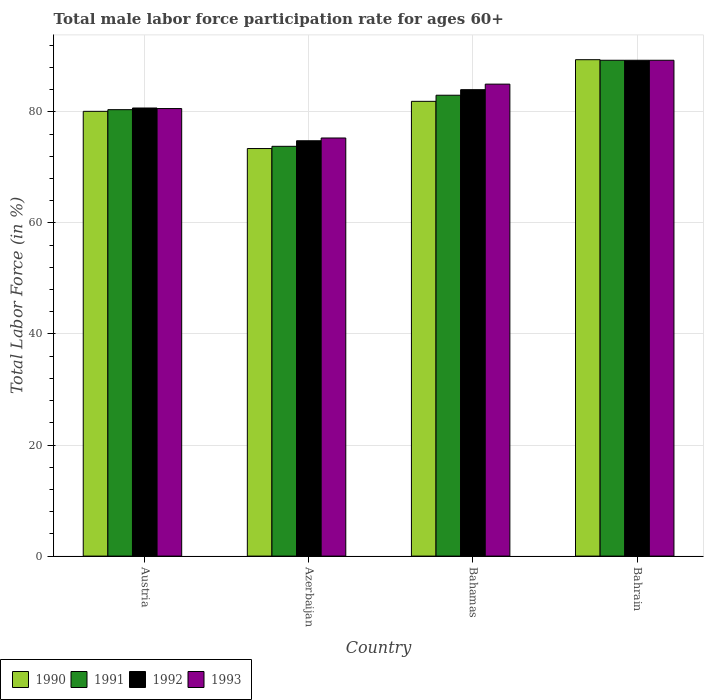What is the label of the 3rd group of bars from the left?
Your response must be concise. Bahamas. What is the male labor force participation rate in 1990 in Austria?
Your response must be concise. 80.1. Across all countries, what is the maximum male labor force participation rate in 1992?
Your response must be concise. 89.3. Across all countries, what is the minimum male labor force participation rate in 1990?
Offer a very short reply. 73.4. In which country was the male labor force participation rate in 1993 maximum?
Provide a short and direct response. Bahrain. In which country was the male labor force participation rate in 1992 minimum?
Make the answer very short. Azerbaijan. What is the total male labor force participation rate in 1990 in the graph?
Your response must be concise. 324.8. What is the difference between the male labor force participation rate in 1991 in Bahamas and that in Bahrain?
Make the answer very short. -6.3. What is the difference between the male labor force participation rate in 1992 in Bahamas and the male labor force participation rate in 1990 in Bahrain?
Make the answer very short. -5.4. What is the average male labor force participation rate in 1990 per country?
Make the answer very short. 81.2. What is the difference between the male labor force participation rate of/in 1992 and male labor force participation rate of/in 1993 in Austria?
Offer a very short reply. 0.1. In how many countries, is the male labor force participation rate in 1993 greater than 56 %?
Offer a terse response. 4. What is the ratio of the male labor force participation rate in 1990 in Bahamas to that in Bahrain?
Offer a terse response. 0.92. Is the male labor force participation rate in 1992 in Austria less than that in Bahamas?
Provide a short and direct response. Yes. Is the difference between the male labor force participation rate in 1992 in Bahamas and Bahrain greater than the difference between the male labor force participation rate in 1993 in Bahamas and Bahrain?
Make the answer very short. No. What is the difference between the highest and the second highest male labor force participation rate in 1990?
Offer a terse response. -7.5. What is the difference between the highest and the lowest male labor force participation rate in 1990?
Ensure brevity in your answer.  16. What does the 1st bar from the right in Austria represents?
Your answer should be very brief. 1993. Are all the bars in the graph horizontal?
Offer a very short reply. No. How many countries are there in the graph?
Offer a very short reply. 4. Are the values on the major ticks of Y-axis written in scientific E-notation?
Keep it short and to the point. No. Does the graph contain any zero values?
Provide a succinct answer. No. Does the graph contain grids?
Your answer should be very brief. Yes. Where does the legend appear in the graph?
Your response must be concise. Bottom left. How many legend labels are there?
Your response must be concise. 4. What is the title of the graph?
Ensure brevity in your answer.  Total male labor force participation rate for ages 60+. Does "1970" appear as one of the legend labels in the graph?
Keep it short and to the point. No. What is the label or title of the Y-axis?
Your answer should be very brief. Total Labor Force (in %). What is the Total Labor Force (in %) in 1990 in Austria?
Provide a succinct answer. 80.1. What is the Total Labor Force (in %) of 1991 in Austria?
Provide a short and direct response. 80.4. What is the Total Labor Force (in %) in 1992 in Austria?
Make the answer very short. 80.7. What is the Total Labor Force (in %) in 1993 in Austria?
Make the answer very short. 80.6. What is the Total Labor Force (in %) in 1990 in Azerbaijan?
Provide a short and direct response. 73.4. What is the Total Labor Force (in %) of 1991 in Azerbaijan?
Give a very brief answer. 73.8. What is the Total Labor Force (in %) of 1992 in Azerbaijan?
Keep it short and to the point. 74.8. What is the Total Labor Force (in %) in 1993 in Azerbaijan?
Provide a succinct answer. 75.3. What is the Total Labor Force (in %) of 1990 in Bahamas?
Make the answer very short. 81.9. What is the Total Labor Force (in %) of 1993 in Bahamas?
Your response must be concise. 85. What is the Total Labor Force (in %) of 1990 in Bahrain?
Offer a terse response. 89.4. What is the Total Labor Force (in %) in 1991 in Bahrain?
Provide a succinct answer. 89.3. What is the Total Labor Force (in %) of 1992 in Bahrain?
Give a very brief answer. 89.3. What is the Total Labor Force (in %) in 1993 in Bahrain?
Ensure brevity in your answer.  89.3. Across all countries, what is the maximum Total Labor Force (in %) in 1990?
Provide a succinct answer. 89.4. Across all countries, what is the maximum Total Labor Force (in %) in 1991?
Your answer should be compact. 89.3. Across all countries, what is the maximum Total Labor Force (in %) in 1992?
Your answer should be compact. 89.3. Across all countries, what is the maximum Total Labor Force (in %) in 1993?
Provide a short and direct response. 89.3. Across all countries, what is the minimum Total Labor Force (in %) in 1990?
Your answer should be compact. 73.4. Across all countries, what is the minimum Total Labor Force (in %) in 1991?
Your answer should be very brief. 73.8. Across all countries, what is the minimum Total Labor Force (in %) in 1992?
Keep it short and to the point. 74.8. Across all countries, what is the minimum Total Labor Force (in %) in 1993?
Your answer should be compact. 75.3. What is the total Total Labor Force (in %) of 1990 in the graph?
Give a very brief answer. 324.8. What is the total Total Labor Force (in %) in 1991 in the graph?
Provide a short and direct response. 326.5. What is the total Total Labor Force (in %) of 1992 in the graph?
Provide a short and direct response. 328.8. What is the total Total Labor Force (in %) in 1993 in the graph?
Make the answer very short. 330.2. What is the difference between the Total Labor Force (in %) in 1990 in Austria and that in Azerbaijan?
Keep it short and to the point. 6.7. What is the difference between the Total Labor Force (in %) in 1992 in Austria and that in Azerbaijan?
Give a very brief answer. 5.9. What is the difference between the Total Labor Force (in %) of 1993 in Austria and that in Azerbaijan?
Offer a terse response. 5.3. What is the difference between the Total Labor Force (in %) of 1990 in Austria and that in Bahamas?
Provide a short and direct response. -1.8. What is the difference between the Total Labor Force (in %) of 1991 in Austria and that in Bahamas?
Offer a terse response. -2.6. What is the difference between the Total Labor Force (in %) in 1992 in Austria and that in Bahamas?
Give a very brief answer. -3.3. What is the difference between the Total Labor Force (in %) of 1992 in Austria and that in Bahrain?
Your answer should be compact. -8.6. What is the difference between the Total Labor Force (in %) of 1990 in Azerbaijan and that in Bahamas?
Offer a very short reply. -8.5. What is the difference between the Total Labor Force (in %) in 1990 in Azerbaijan and that in Bahrain?
Make the answer very short. -16. What is the difference between the Total Labor Force (in %) in 1991 in Azerbaijan and that in Bahrain?
Offer a terse response. -15.5. What is the difference between the Total Labor Force (in %) in 1993 in Azerbaijan and that in Bahrain?
Provide a short and direct response. -14. What is the difference between the Total Labor Force (in %) in 1990 in Bahamas and that in Bahrain?
Make the answer very short. -7.5. What is the difference between the Total Labor Force (in %) of 1993 in Bahamas and that in Bahrain?
Your answer should be compact. -4.3. What is the difference between the Total Labor Force (in %) of 1992 in Austria and the Total Labor Force (in %) of 1993 in Azerbaijan?
Your answer should be very brief. 5.4. What is the difference between the Total Labor Force (in %) of 1990 in Austria and the Total Labor Force (in %) of 1992 in Bahamas?
Offer a very short reply. -3.9. What is the difference between the Total Labor Force (in %) in 1990 in Austria and the Total Labor Force (in %) in 1993 in Bahamas?
Provide a short and direct response. -4.9. What is the difference between the Total Labor Force (in %) in 1991 in Austria and the Total Labor Force (in %) in 1993 in Bahamas?
Your answer should be very brief. -4.6. What is the difference between the Total Labor Force (in %) of 1990 in Austria and the Total Labor Force (in %) of 1992 in Bahrain?
Your response must be concise. -9.2. What is the difference between the Total Labor Force (in %) of 1991 in Austria and the Total Labor Force (in %) of 1993 in Bahrain?
Ensure brevity in your answer.  -8.9. What is the difference between the Total Labor Force (in %) of 1992 in Austria and the Total Labor Force (in %) of 1993 in Bahrain?
Provide a short and direct response. -8.6. What is the difference between the Total Labor Force (in %) of 1990 in Azerbaijan and the Total Labor Force (in %) of 1991 in Bahamas?
Give a very brief answer. -9.6. What is the difference between the Total Labor Force (in %) in 1990 in Azerbaijan and the Total Labor Force (in %) in 1992 in Bahamas?
Give a very brief answer. -10.6. What is the difference between the Total Labor Force (in %) in 1991 in Azerbaijan and the Total Labor Force (in %) in 1992 in Bahamas?
Provide a succinct answer. -10.2. What is the difference between the Total Labor Force (in %) in 1991 in Azerbaijan and the Total Labor Force (in %) in 1993 in Bahamas?
Offer a very short reply. -11.2. What is the difference between the Total Labor Force (in %) in 1990 in Azerbaijan and the Total Labor Force (in %) in 1991 in Bahrain?
Keep it short and to the point. -15.9. What is the difference between the Total Labor Force (in %) in 1990 in Azerbaijan and the Total Labor Force (in %) in 1992 in Bahrain?
Provide a succinct answer. -15.9. What is the difference between the Total Labor Force (in %) of 1990 in Azerbaijan and the Total Labor Force (in %) of 1993 in Bahrain?
Make the answer very short. -15.9. What is the difference between the Total Labor Force (in %) of 1991 in Azerbaijan and the Total Labor Force (in %) of 1992 in Bahrain?
Your answer should be compact. -15.5. What is the difference between the Total Labor Force (in %) of 1991 in Azerbaijan and the Total Labor Force (in %) of 1993 in Bahrain?
Offer a very short reply. -15.5. What is the difference between the Total Labor Force (in %) of 1992 in Azerbaijan and the Total Labor Force (in %) of 1993 in Bahrain?
Offer a terse response. -14.5. What is the difference between the Total Labor Force (in %) in 1990 in Bahamas and the Total Labor Force (in %) in 1993 in Bahrain?
Offer a very short reply. -7.4. What is the difference between the Total Labor Force (in %) of 1991 in Bahamas and the Total Labor Force (in %) of 1993 in Bahrain?
Offer a very short reply. -6.3. What is the average Total Labor Force (in %) in 1990 per country?
Provide a succinct answer. 81.2. What is the average Total Labor Force (in %) of 1991 per country?
Offer a very short reply. 81.62. What is the average Total Labor Force (in %) in 1992 per country?
Offer a very short reply. 82.2. What is the average Total Labor Force (in %) of 1993 per country?
Offer a very short reply. 82.55. What is the difference between the Total Labor Force (in %) in 1990 and Total Labor Force (in %) in 1991 in Austria?
Your response must be concise. -0.3. What is the difference between the Total Labor Force (in %) in 1990 and Total Labor Force (in %) in 1992 in Azerbaijan?
Your answer should be very brief. -1.4. What is the difference between the Total Labor Force (in %) of 1991 and Total Labor Force (in %) of 1992 in Azerbaijan?
Your response must be concise. -1. What is the difference between the Total Labor Force (in %) in 1991 and Total Labor Force (in %) in 1993 in Azerbaijan?
Ensure brevity in your answer.  -1.5. What is the difference between the Total Labor Force (in %) in 1992 and Total Labor Force (in %) in 1993 in Azerbaijan?
Provide a short and direct response. -0.5. What is the difference between the Total Labor Force (in %) in 1990 and Total Labor Force (in %) in 1991 in Bahamas?
Your answer should be very brief. -1.1. What is the difference between the Total Labor Force (in %) of 1991 and Total Labor Force (in %) of 1993 in Bahamas?
Make the answer very short. -2. What is the difference between the Total Labor Force (in %) of 1992 and Total Labor Force (in %) of 1993 in Bahamas?
Provide a short and direct response. -1. What is the difference between the Total Labor Force (in %) in 1990 and Total Labor Force (in %) in 1993 in Bahrain?
Provide a short and direct response. 0.1. What is the difference between the Total Labor Force (in %) of 1992 and Total Labor Force (in %) of 1993 in Bahrain?
Your answer should be compact. 0. What is the ratio of the Total Labor Force (in %) in 1990 in Austria to that in Azerbaijan?
Offer a very short reply. 1.09. What is the ratio of the Total Labor Force (in %) in 1991 in Austria to that in Azerbaijan?
Make the answer very short. 1.09. What is the ratio of the Total Labor Force (in %) of 1992 in Austria to that in Azerbaijan?
Give a very brief answer. 1.08. What is the ratio of the Total Labor Force (in %) of 1993 in Austria to that in Azerbaijan?
Keep it short and to the point. 1.07. What is the ratio of the Total Labor Force (in %) in 1991 in Austria to that in Bahamas?
Ensure brevity in your answer.  0.97. What is the ratio of the Total Labor Force (in %) in 1992 in Austria to that in Bahamas?
Offer a very short reply. 0.96. What is the ratio of the Total Labor Force (in %) in 1993 in Austria to that in Bahamas?
Your response must be concise. 0.95. What is the ratio of the Total Labor Force (in %) of 1990 in Austria to that in Bahrain?
Provide a succinct answer. 0.9. What is the ratio of the Total Labor Force (in %) in 1991 in Austria to that in Bahrain?
Make the answer very short. 0.9. What is the ratio of the Total Labor Force (in %) of 1992 in Austria to that in Bahrain?
Give a very brief answer. 0.9. What is the ratio of the Total Labor Force (in %) of 1993 in Austria to that in Bahrain?
Your response must be concise. 0.9. What is the ratio of the Total Labor Force (in %) of 1990 in Azerbaijan to that in Bahamas?
Provide a short and direct response. 0.9. What is the ratio of the Total Labor Force (in %) of 1991 in Azerbaijan to that in Bahamas?
Your response must be concise. 0.89. What is the ratio of the Total Labor Force (in %) of 1992 in Azerbaijan to that in Bahamas?
Offer a terse response. 0.89. What is the ratio of the Total Labor Force (in %) of 1993 in Azerbaijan to that in Bahamas?
Give a very brief answer. 0.89. What is the ratio of the Total Labor Force (in %) in 1990 in Azerbaijan to that in Bahrain?
Provide a short and direct response. 0.82. What is the ratio of the Total Labor Force (in %) of 1991 in Azerbaijan to that in Bahrain?
Provide a short and direct response. 0.83. What is the ratio of the Total Labor Force (in %) of 1992 in Azerbaijan to that in Bahrain?
Make the answer very short. 0.84. What is the ratio of the Total Labor Force (in %) of 1993 in Azerbaijan to that in Bahrain?
Your answer should be compact. 0.84. What is the ratio of the Total Labor Force (in %) of 1990 in Bahamas to that in Bahrain?
Keep it short and to the point. 0.92. What is the ratio of the Total Labor Force (in %) in 1991 in Bahamas to that in Bahrain?
Your answer should be very brief. 0.93. What is the ratio of the Total Labor Force (in %) in 1992 in Bahamas to that in Bahrain?
Your answer should be compact. 0.94. What is the ratio of the Total Labor Force (in %) in 1993 in Bahamas to that in Bahrain?
Provide a short and direct response. 0.95. What is the difference between the highest and the second highest Total Labor Force (in %) in 1990?
Keep it short and to the point. 7.5. What is the difference between the highest and the second highest Total Labor Force (in %) in 1992?
Provide a short and direct response. 5.3. 